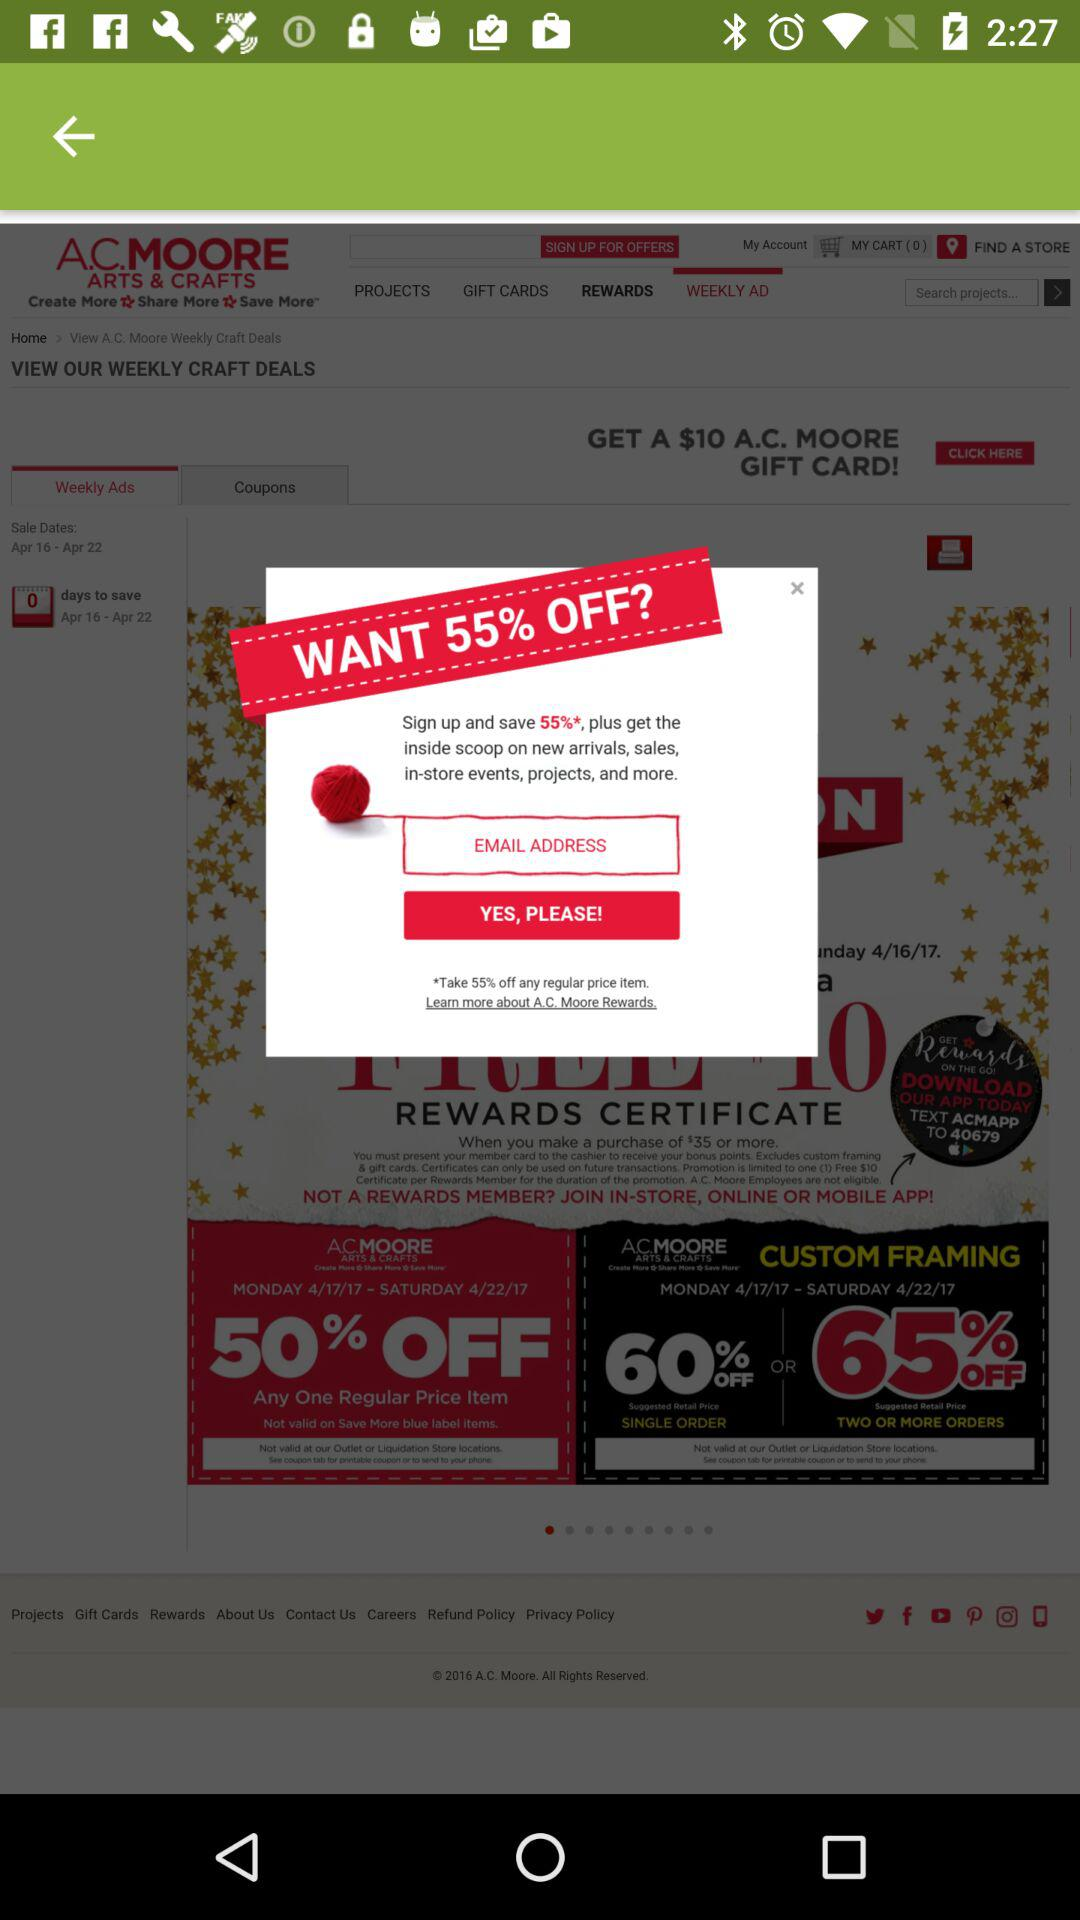What to do to get 55% off? Get 55% off by signing up. 